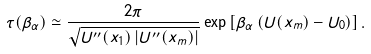Convert formula to latex. <formula><loc_0><loc_0><loc_500><loc_500>\tau ( \beta _ { \alpha } ) \simeq \frac { 2 \pi } { \sqrt { U ^ { \prime \prime } ( x _ { 1 } ) \left | U ^ { \prime \prime } ( x _ { m } ) \right | } } \exp \left [ \beta _ { \alpha } \left ( U ( x _ { m } ) - U _ { 0 } \right ) \right ] .</formula> 